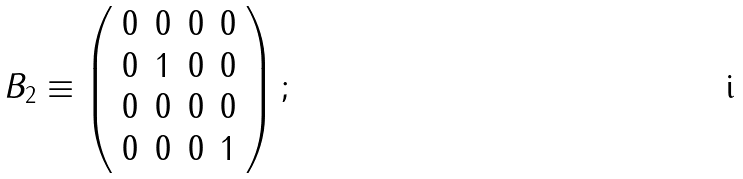<formula> <loc_0><loc_0><loc_500><loc_500>B _ { 2 } \equiv \left ( \begin{array} { c c c c } 0 & 0 & 0 & 0 \\ 0 & 1 & 0 & 0 \\ 0 & 0 & 0 & 0 \\ 0 & 0 & 0 & 1 \end{array} \right ) ;</formula> 